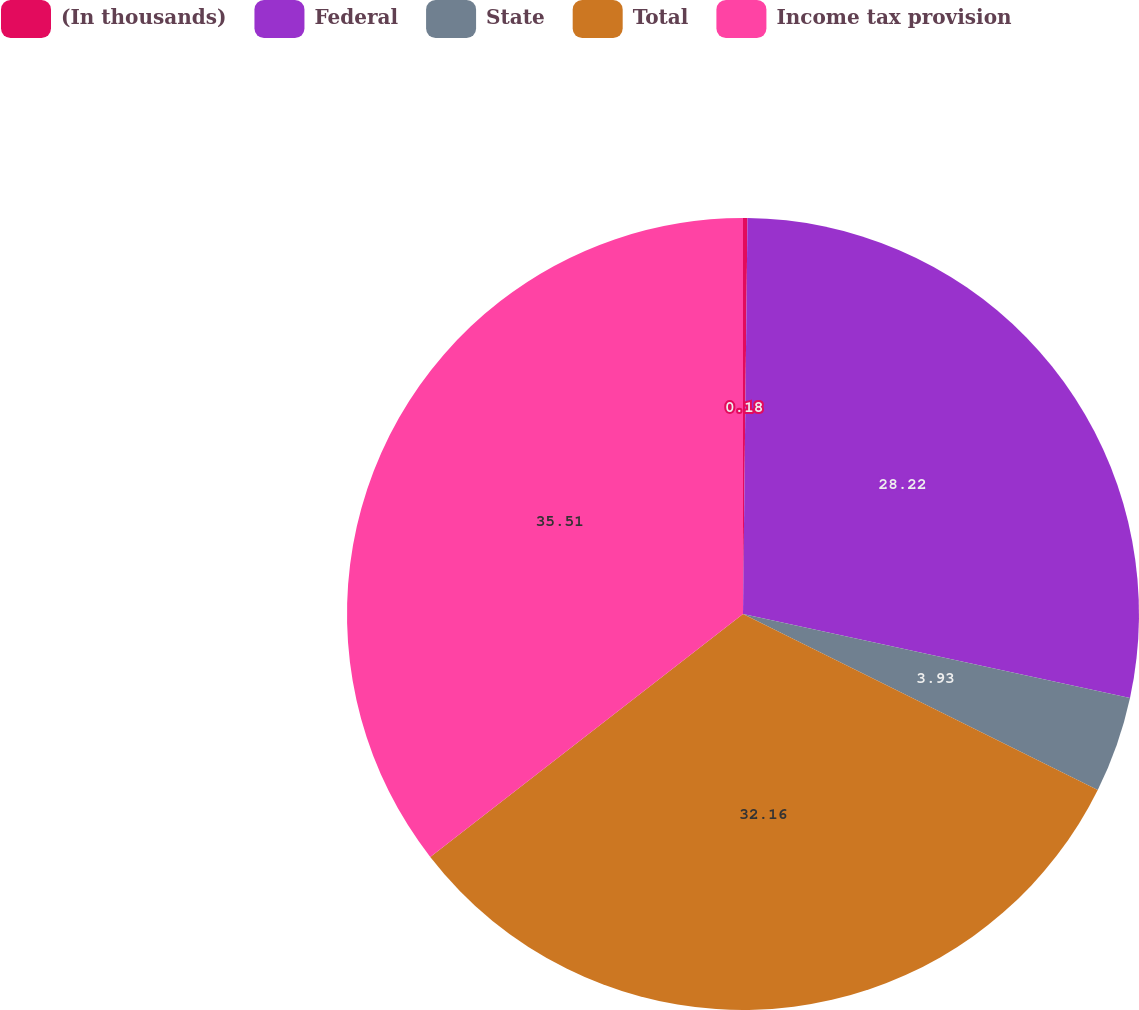Convert chart to OTSL. <chart><loc_0><loc_0><loc_500><loc_500><pie_chart><fcel>(In thousands)<fcel>Federal<fcel>State<fcel>Total<fcel>Income tax provision<nl><fcel>0.18%<fcel>28.22%<fcel>3.93%<fcel>32.16%<fcel>35.51%<nl></chart> 